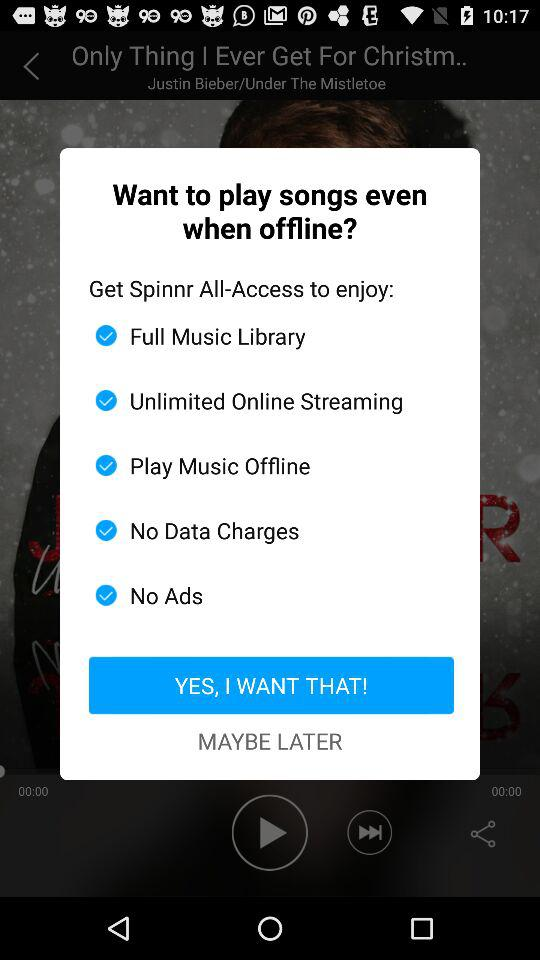How many features are offered by Spinnr All-Access?
Answer the question using a single word or phrase. 5 